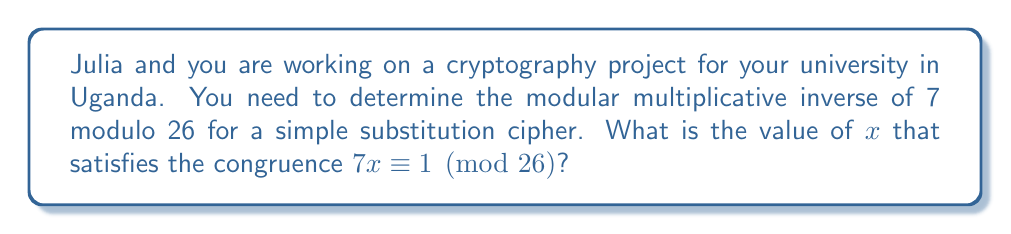Show me your answer to this math problem. To find the modular multiplicative inverse, we need to solve the congruence:

$7x \equiv 1 \pmod{26}$

We can use the extended Euclidean algorithm to find the solution:

1) First, apply the division algorithm to 26 and 7:
   $26 = 3 \cdot 7 + 5$

2) Then, apply it to 7 and 5:
   $7 = 1 \cdot 5 + 2$

3) Finally, apply it to 5 and 2:
   $5 = 2 \cdot 2 + 1$

4) Now, work backwards to express 1 as a linear combination of 26 and 7:
   $1 = 5 - 2 \cdot 2$
   $1 = 5 - 2 \cdot (7 - 1 \cdot 5) = 3 \cdot 5 - 2 \cdot 7$
   $1 = 3 \cdot (26 - 3 \cdot 7) - 2 \cdot 7 = 3 \cdot 26 - 11 \cdot 7$

5) Therefore, $-11 \cdot 7 \equiv 1 \pmod{26}$

6) Simplify $-11$ modulo 26:
   $-11 \equiv 15 \pmod{26}$

Thus, $15 \cdot 7 \equiv 1 \pmod{26}$, so 15 is the modular multiplicative inverse of 7 modulo 26.
Answer: 15 